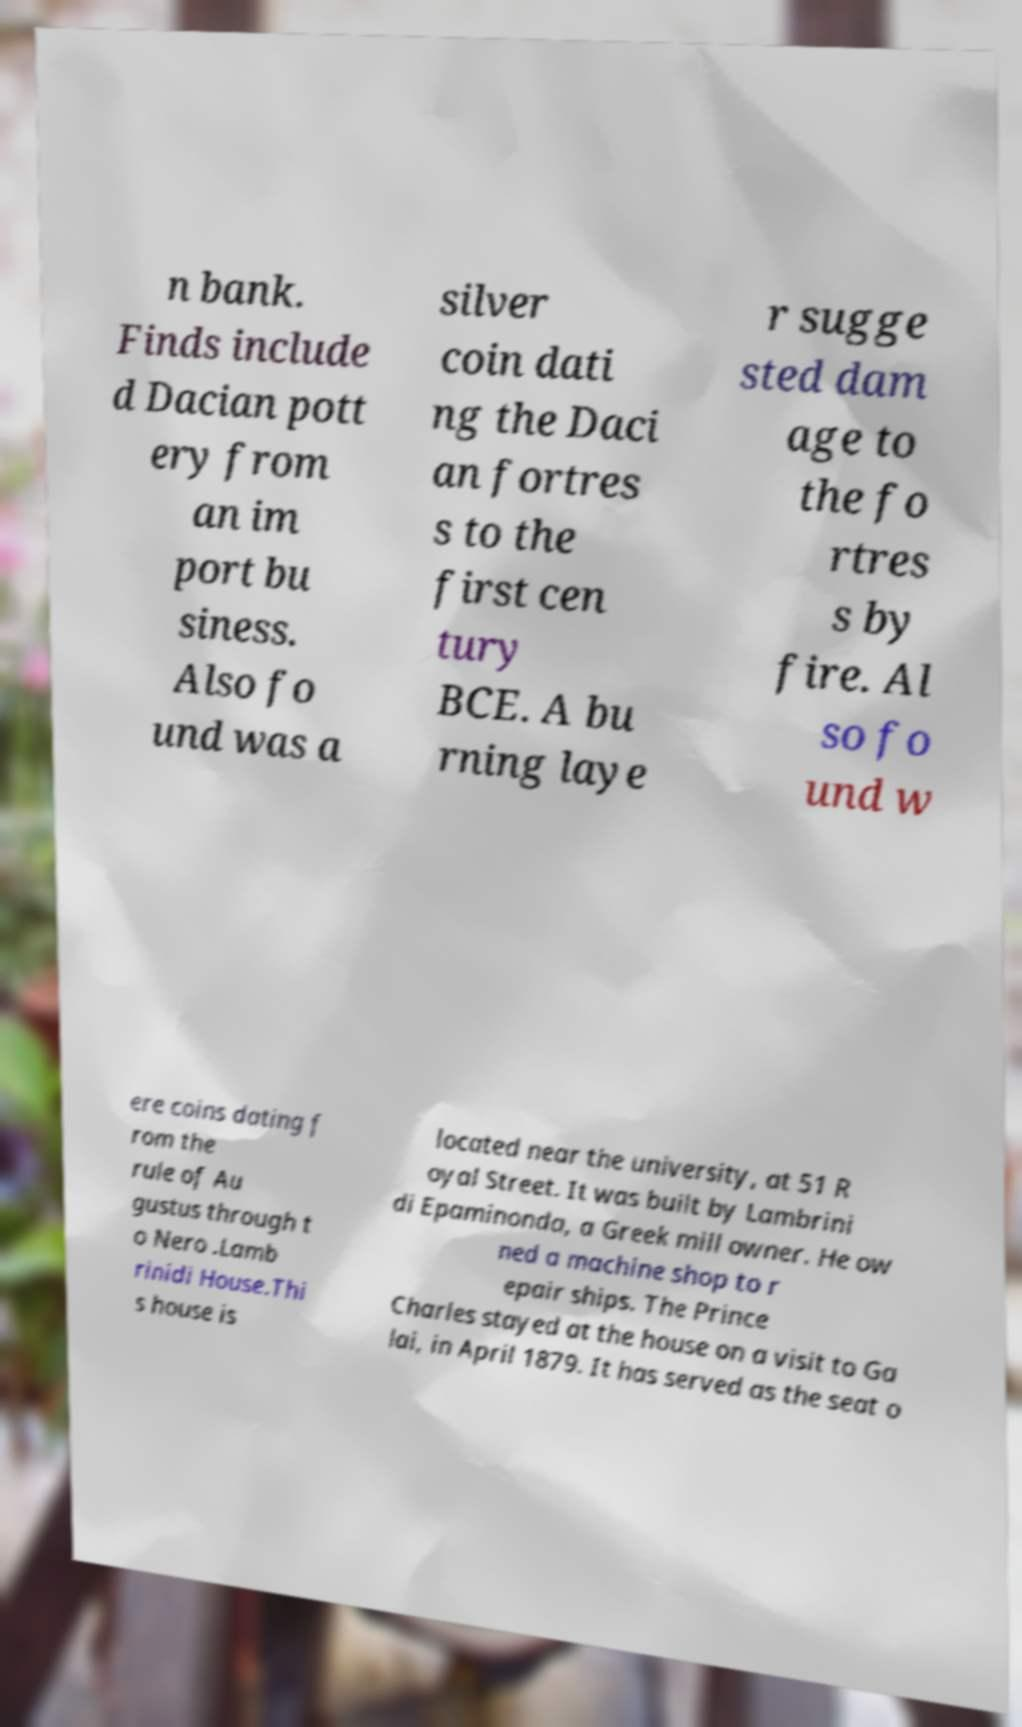What messages or text are displayed in this image? I need them in a readable, typed format. n bank. Finds include d Dacian pott ery from an im port bu siness. Also fo und was a silver coin dati ng the Daci an fortres s to the first cen tury BCE. A bu rning laye r sugge sted dam age to the fo rtres s by fire. Al so fo und w ere coins dating f rom the rule of Au gustus through t o Nero .Lamb rinidi House.Thi s house is located near the university, at 51 R oyal Street. It was built by Lambrini di Epaminonda, a Greek mill owner. He ow ned a machine shop to r epair ships. The Prince Charles stayed at the house on a visit to Ga lai, in April 1879. It has served as the seat o 